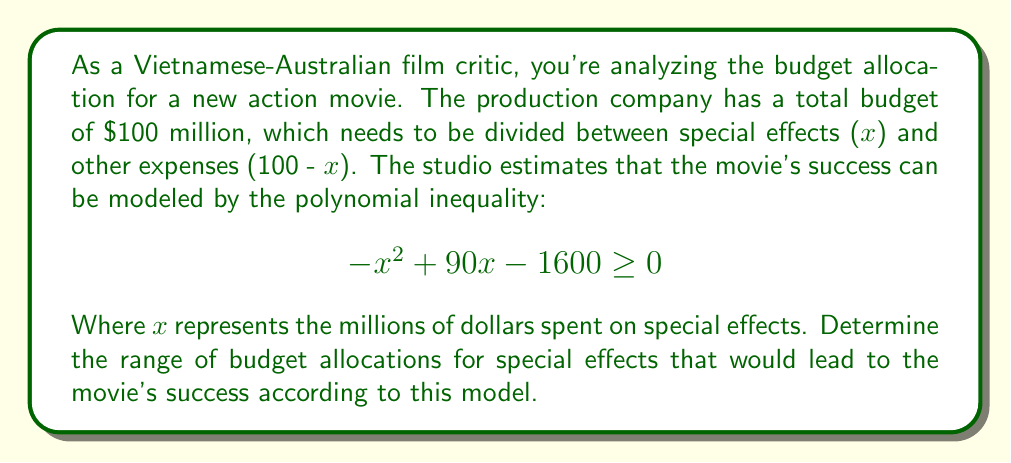Could you help me with this problem? To solve this polynomial inequality, we need to follow these steps:

1) First, we need to find the roots of the quadratic equation:
   $$ -x^2 + 90x - 1600 = 0 $$

2) We can solve this using the quadratic formula: $x = \frac{-b \pm \sqrt{b^2 - 4ac}}{2a}$
   Where $a = -1$, $b = 90$, and $c = -1600$

3) Plugging these values into the quadratic formula:
   $$ x = \frac{-90 \pm \sqrt{90^2 - 4(-1)(-1600)}}{2(-1)} $$
   $$ = \frac{-90 \pm \sqrt{8100 - 6400}}{-2} $$
   $$ = \frac{-90 \pm \sqrt{1700}}{-2} $$
   $$ = \frac{-90 \pm 41.23}{-2} $$

4) This gives us two solutions:
   $$ x_1 = \frac{-90 + 41.23}{-2} \approx 24.38 $$
   $$ x_2 = \frac{-90 - 41.23}{-2} \approx 65.62 $$

5) The inequality is $\geq 0$, which means the parabola opens downward (because the coefficient of $x^2$ is negative). Therefore, the solution to the inequality is all values of x between these two roots.

6) Rounding to the nearest million (as we're dealing with millions of dollars), the range for x is [25, 65].

Therefore, the movie is predicted to be successful if the special effects budget is between $25 million and $65 million.
Answer: The range of budget allocations for special effects that would lead to the movie's success is $25 million ≤ x ≤ $65 million. 